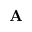Convert formula to latex. <formula><loc_0><loc_0><loc_500><loc_500>{ A }</formula> 